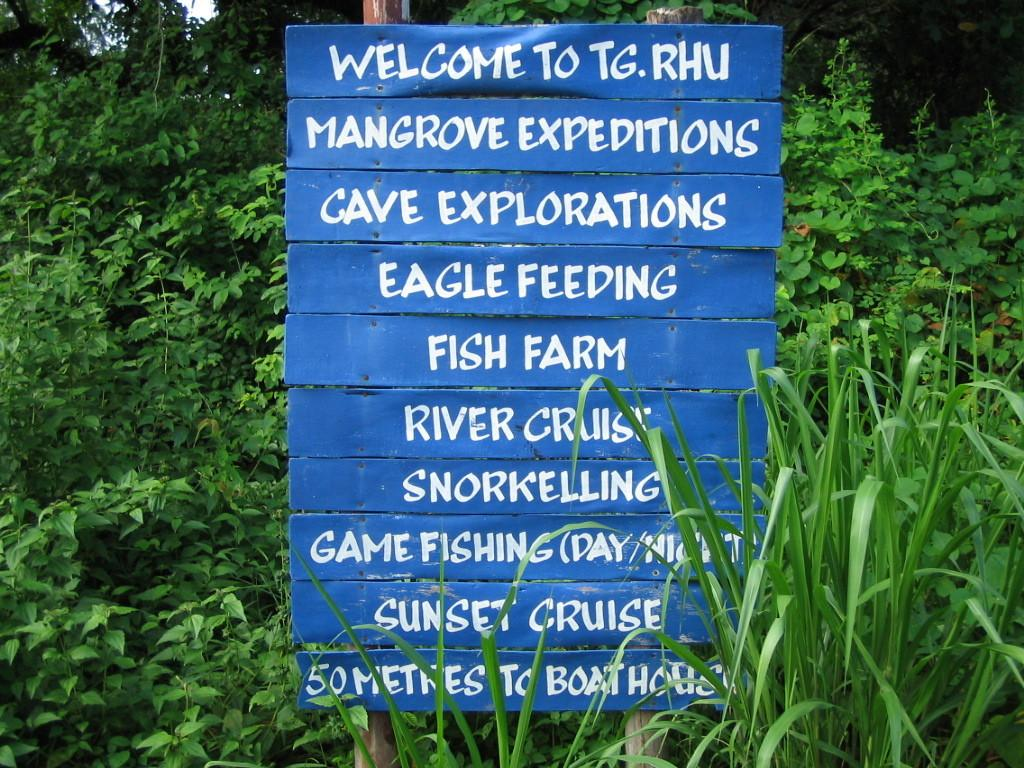What is on the board that is visible in the image? There is text on the board in the image. How is the board supported in the image? The board is present on poles. What is covering the board in the image? The board is covered with plants. What type of vegetation is present around the board in the image? Trees are present around the board. What type of cart is being pulled by the corn in the image? There is no cart or corn present in the image. 